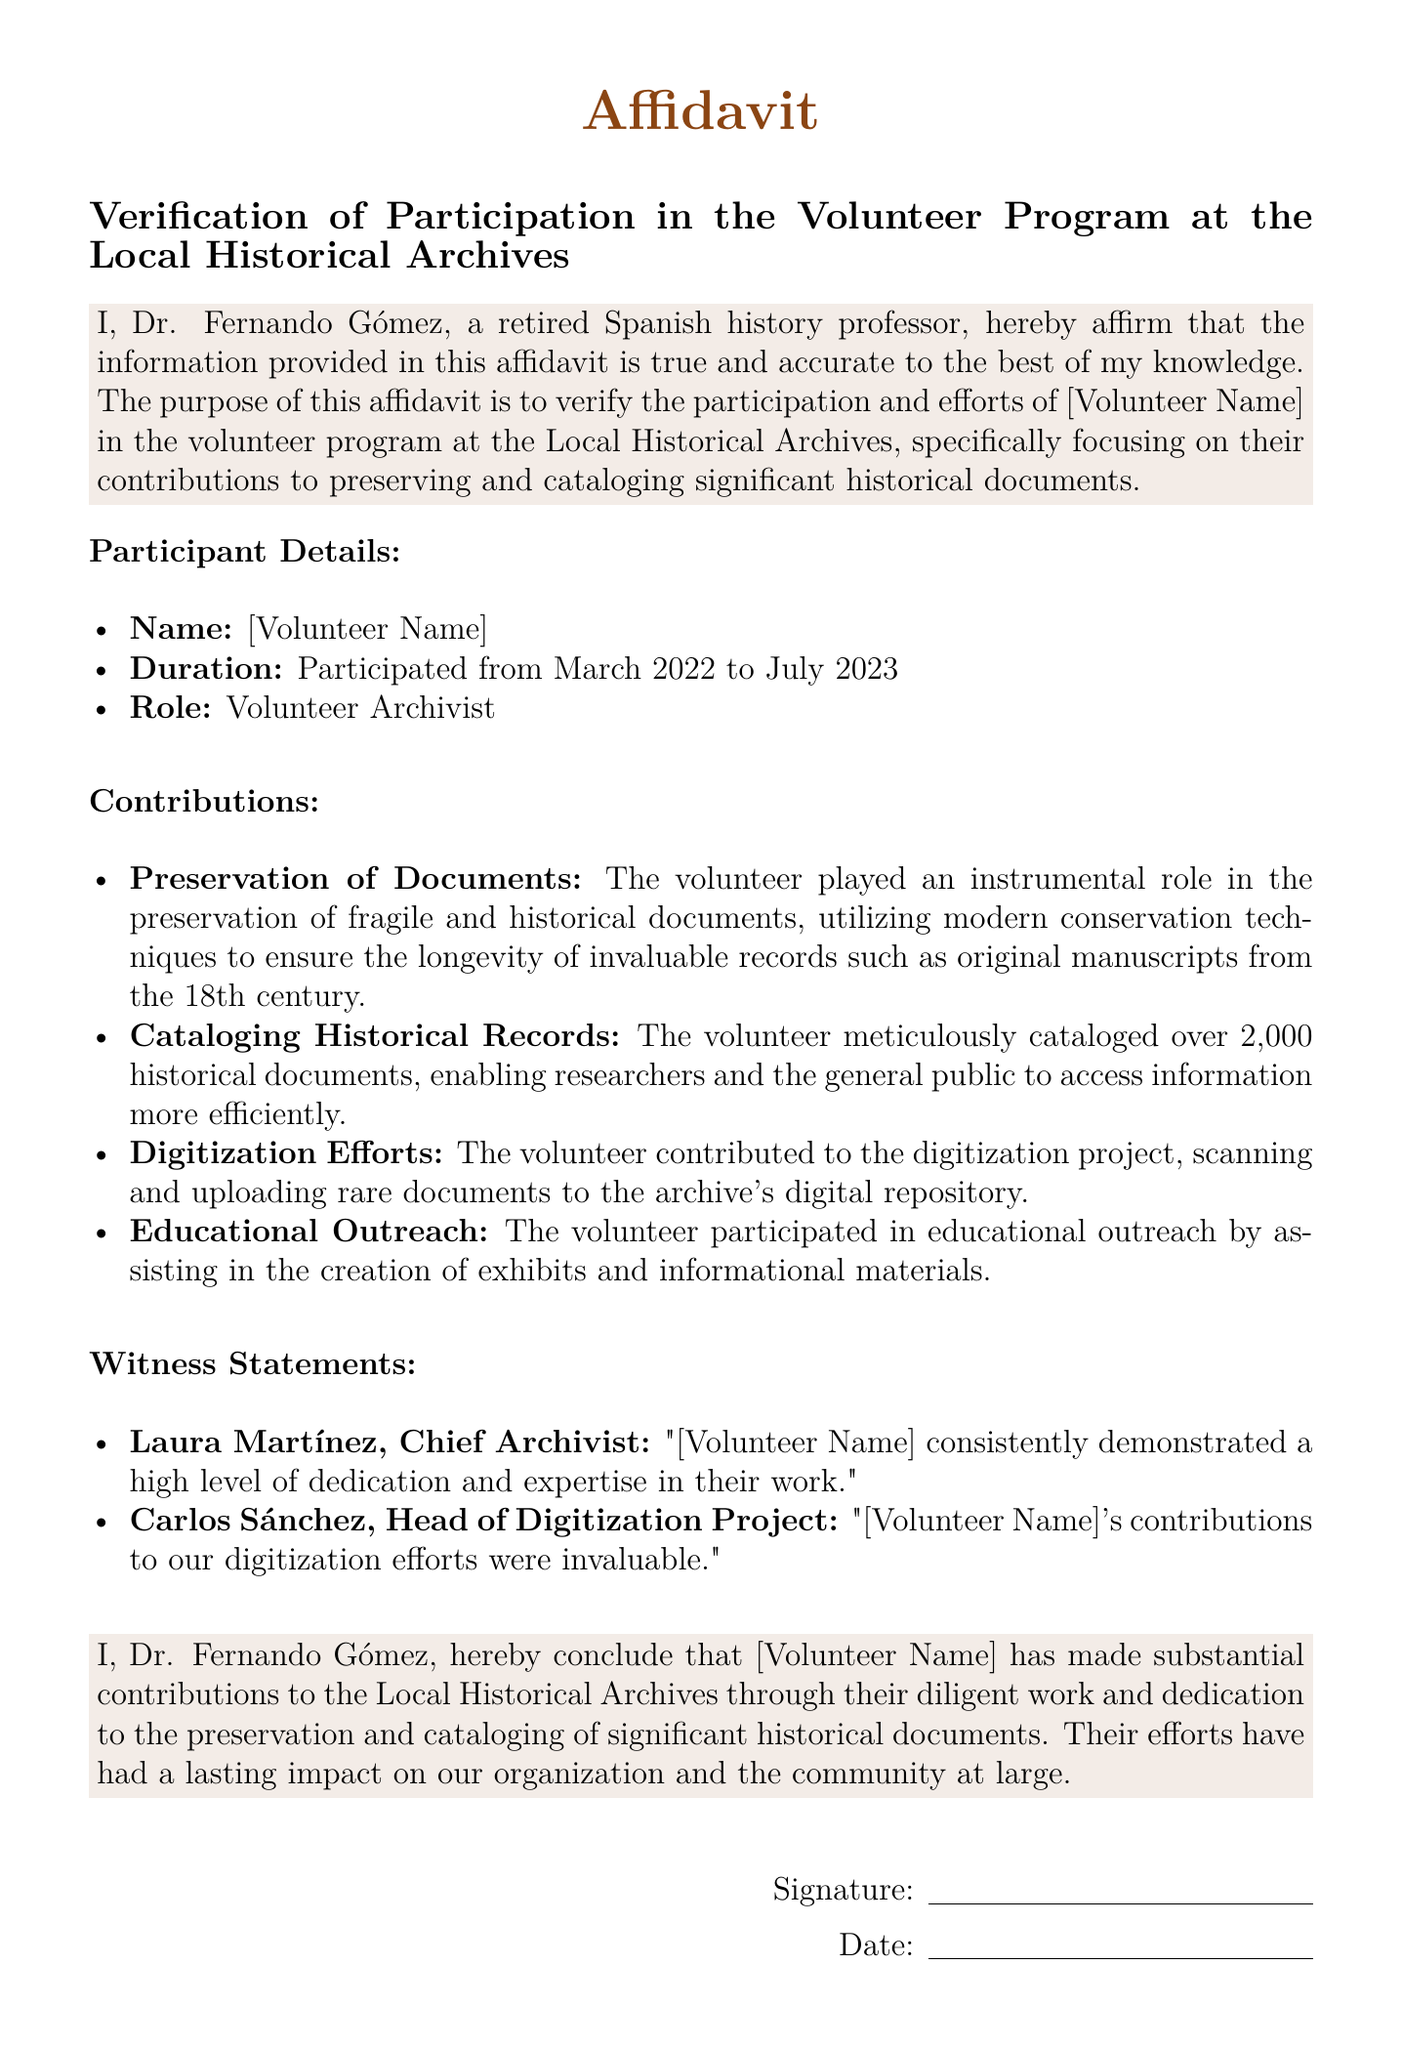What is the name of the volunteer? The document provides the name of the volunteer as [Volunteer Name].
Answer: [Volunteer Name] What was the duration of the volunteer's participation? The document states that the volunteer participated from March 2022 to July 2023.
Answer: March 2022 to July 2023 What role did the volunteer serve in the program? The document specifies that the volunteer's role was Volunteer Archivist.
Answer: Volunteer Archivist How many historical documents did the volunteer catalog? The document mentions that over 2,000 historical documents were cataloged by the volunteer.
Answer: 2,000 Who is the Chief Archivist that provided a witness statement? The document states that Laura Martínez is the Chief Archivist who provided a statement.
Answer: Laura Martínez What significant conservation technique was used by the volunteer? The document indicates that modern conservation techniques were utilized to preserve documents.
Answer: Modern conservation techniques What type of project did the volunteer contribute to besides preservation? The document mentions that the volunteer contributed to the digitization project.
Answer: Digitization project In what capacity did the volunteer participate in educational outreach? The document specifies that the volunteer assisted in the creation of exhibits and informational materials.
Answer: Creation of exhibits and informational materials What is the title of the affidavit? The document indicates that the title of the affidavit is "Verification of Participation in the Volunteer Program at the Local Historical Archives."
Answer: Verification of Participation in the Volunteer Program at the Local Historical Archives 